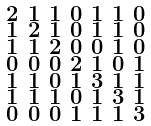<formula> <loc_0><loc_0><loc_500><loc_500>\begin{smallmatrix} 2 & 1 & 1 & 0 & 1 & 1 & 0 \\ 1 & 2 & 1 & 0 & 1 & 1 & 0 \\ 1 & 1 & 2 & 0 & 0 & 1 & 0 \\ 0 & 0 & 0 & 2 & 1 & 0 & 1 \\ 1 & 1 & 0 & 1 & 3 & 1 & 1 \\ 1 & 1 & 1 & 0 & 1 & 3 & 1 \\ 0 & 0 & 0 & 1 & 1 & 1 & 3 \end{smallmatrix}</formula> 